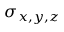Convert formula to latex. <formula><loc_0><loc_0><loc_500><loc_500>\sigma _ { x , y , z }</formula> 